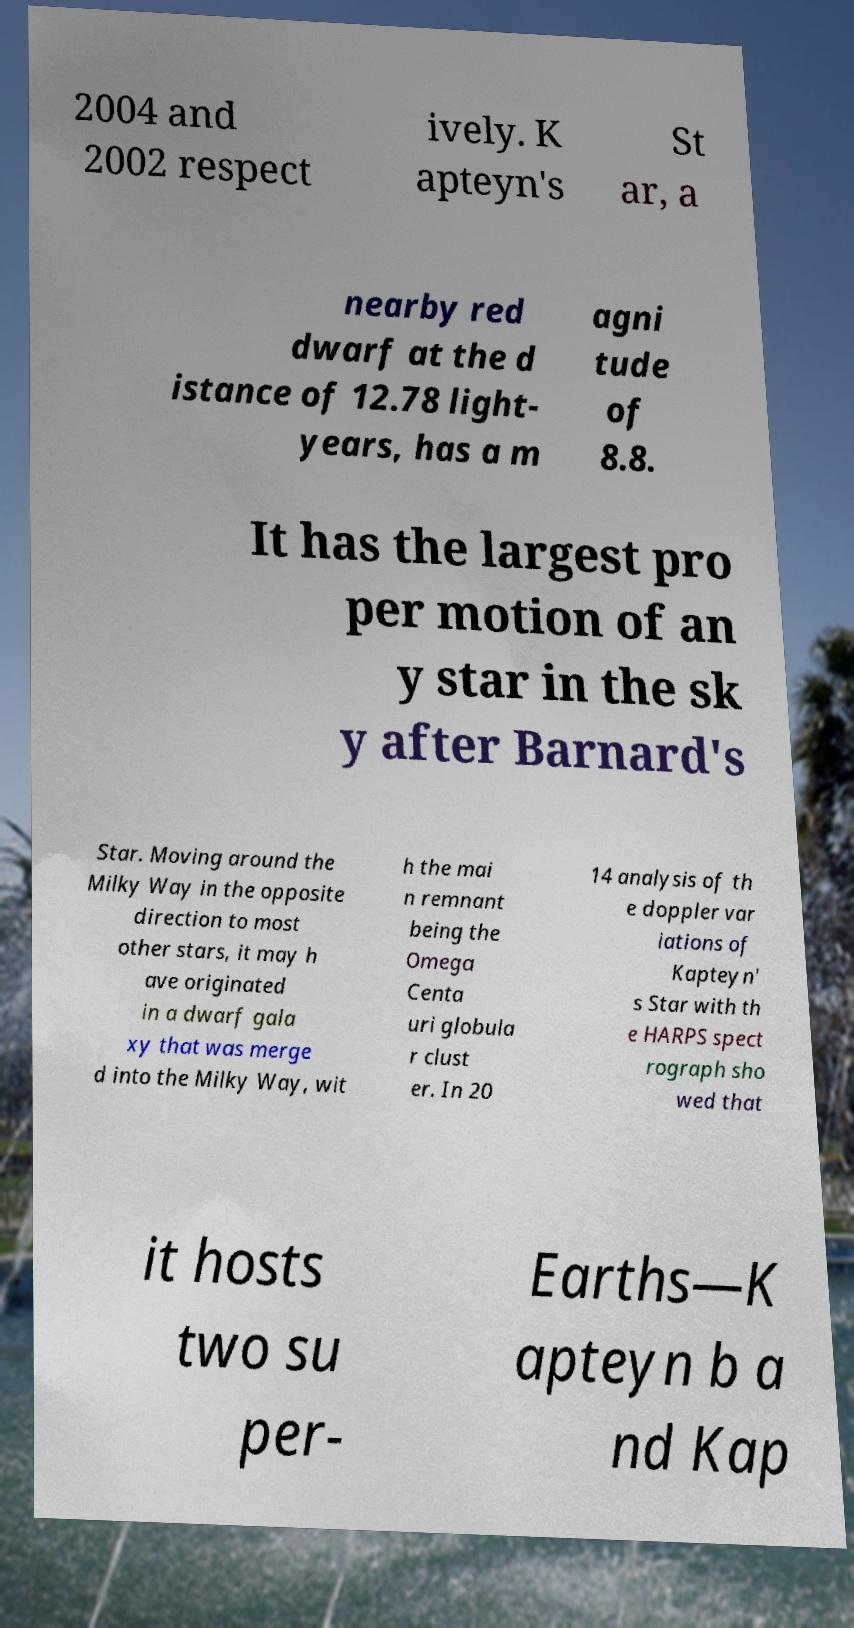Could you extract and type out the text from this image? 2004 and 2002 respect ively. K apteyn's St ar, a nearby red dwarf at the d istance of 12.78 light- years, has a m agni tude of 8.8. It has the largest pro per motion of an y star in the sk y after Barnard's Star. Moving around the Milky Way in the opposite direction to most other stars, it may h ave originated in a dwarf gala xy that was merge d into the Milky Way, wit h the mai n remnant being the Omega Centa uri globula r clust er. In 20 14 analysis of th e doppler var iations of Kapteyn' s Star with th e HARPS spect rograph sho wed that it hosts two su per- Earths—K apteyn b a nd Kap 